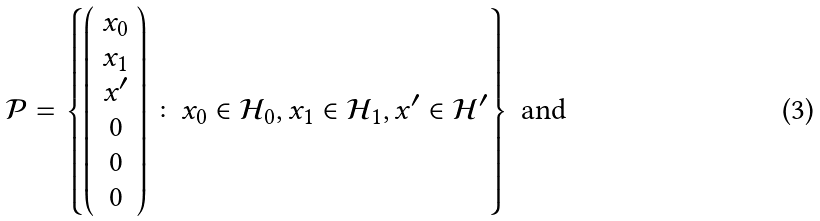<formula> <loc_0><loc_0><loc_500><loc_500>\mathcal { P } & = \left \{ \left ( \begin{array} { c } x _ { 0 } \\ x _ { 1 } \\ x ^ { \prime } \\ 0 \\ 0 \\ 0 \end{array} \right ) \colon x _ { 0 } \in \mathcal { H } _ { 0 } , x _ { 1 } \in \mathcal { H } _ { 1 } , x ^ { \prime } \in \mathcal { H } ^ { \prime } \right \} \text { and }</formula> 